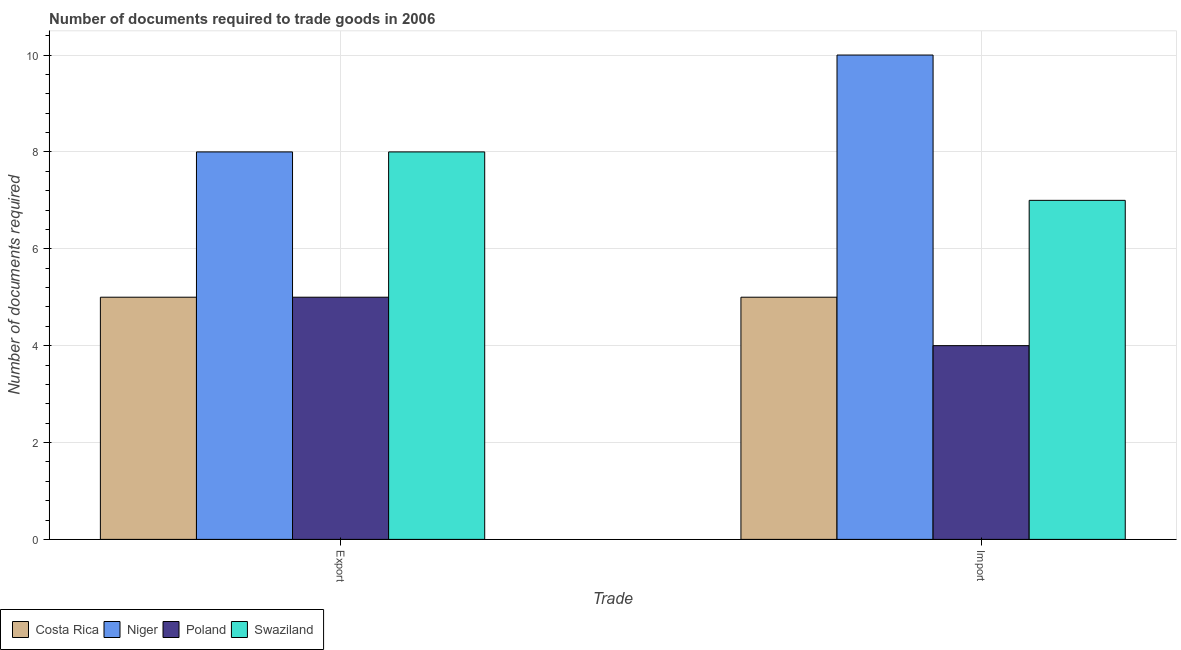How many different coloured bars are there?
Provide a short and direct response. 4. Are the number of bars per tick equal to the number of legend labels?
Ensure brevity in your answer.  Yes. What is the label of the 1st group of bars from the left?
Offer a very short reply. Export. What is the number of documents required to import goods in Costa Rica?
Keep it short and to the point. 5. Across all countries, what is the maximum number of documents required to import goods?
Your answer should be compact. 10. Across all countries, what is the minimum number of documents required to import goods?
Your response must be concise. 4. In which country was the number of documents required to export goods maximum?
Your answer should be compact. Niger. What is the total number of documents required to export goods in the graph?
Make the answer very short. 26. What is the difference between the number of documents required to import goods in Poland and that in Niger?
Ensure brevity in your answer.  -6. What is the difference between the number of documents required to import goods in Swaziland and the number of documents required to export goods in Poland?
Keep it short and to the point. 2. What is the difference between the number of documents required to import goods and number of documents required to export goods in Poland?
Offer a terse response. -1. In how many countries, is the number of documents required to import goods greater than 5.6 ?
Offer a terse response. 2. In how many countries, is the number of documents required to import goods greater than the average number of documents required to import goods taken over all countries?
Offer a terse response. 2. What does the 4th bar from the left in Import represents?
Offer a very short reply. Swaziland. What does the 1st bar from the right in Export represents?
Offer a very short reply. Swaziland. Are all the bars in the graph horizontal?
Ensure brevity in your answer.  No. What is the difference between two consecutive major ticks on the Y-axis?
Ensure brevity in your answer.  2. Are the values on the major ticks of Y-axis written in scientific E-notation?
Provide a succinct answer. No. Where does the legend appear in the graph?
Your answer should be compact. Bottom left. What is the title of the graph?
Your answer should be compact. Number of documents required to trade goods in 2006. Does "Latin America(developing only)" appear as one of the legend labels in the graph?
Keep it short and to the point. No. What is the label or title of the X-axis?
Ensure brevity in your answer.  Trade. What is the label or title of the Y-axis?
Ensure brevity in your answer.  Number of documents required. What is the Number of documents required in Costa Rica in Export?
Your answer should be very brief. 5. What is the Number of documents required in Poland in Export?
Offer a terse response. 5. What is the Number of documents required in Swaziland in Export?
Provide a short and direct response. 8. What is the Number of documents required of Costa Rica in Import?
Ensure brevity in your answer.  5. What is the Number of documents required of Swaziland in Import?
Your response must be concise. 7. Across all Trade, what is the maximum Number of documents required in Niger?
Provide a short and direct response. 10. Across all Trade, what is the maximum Number of documents required in Swaziland?
Your response must be concise. 8. Across all Trade, what is the minimum Number of documents required in Costa Rica?
Offer a very short reply. 5. Across all Trade, what is the minimum Number of documents required in Swaziland?
Give a very brief answer. 7. What is the difference between the Number of documents required in Poland in Export and that in Import?
Your answer should be compact. 1. What is the difference between the Number of documents required in Costa Rica in Export and the Number of documents required in Poland in Import?
Your answer should be compact. 1. What is the difference between the Number of documents required in Costa Rica in Export and the Number of documents required in Swaziland in Import?
Your answer should be very brief. -2. What is the difference between the Number of documents required in Niger in Export and the Number of documents required in Poland in Import?
Offer a terse response. 4. What is the difference between the Number of documents required of Niger in Export and the Number of documents required of Swaziland in Import?
Ensure brevity in your answer.  1. What is the average Number of documents required of Costa Rica per Trade?
Provide a succinct answer. 5. What is the difference between the Number of documents required in Costa Rica and Number of documents required in Poland in Export?
Ensure brevity in your answer.  0. What is the difference between the Number of documents required in Niger and Number of documents required in Poland in Export?
Give a very brief answer. 3. What is the difference between the Number of documents required in Costa Rica and Number of documents required in Niger in Import?
Keep it short and to the point. -5. What is the difference between the Number of documents required of Costa Rica and Number of documents required of Poland in Import?
Your answer should be very brief. 1. What is the difference between the Number of documents required of Costa Rica and Number of documents required of Swaziland in Import?
Offer a terse response. -2. What is the ratio of the Number of documents required of Niger in Export to that in Import?
Offer a very short reply. 0.8. What is the difference between the highest and the second highest Number of documents required of Costa Rica?
Offer a very short reply. 0. What is the difference between the highest and the second highest Number of documents required of Poland?
Provide a short and direct response. 1. What is the difference between the highest and the lowest Number of documents required of Poland?
Offer a terse response. 1. 